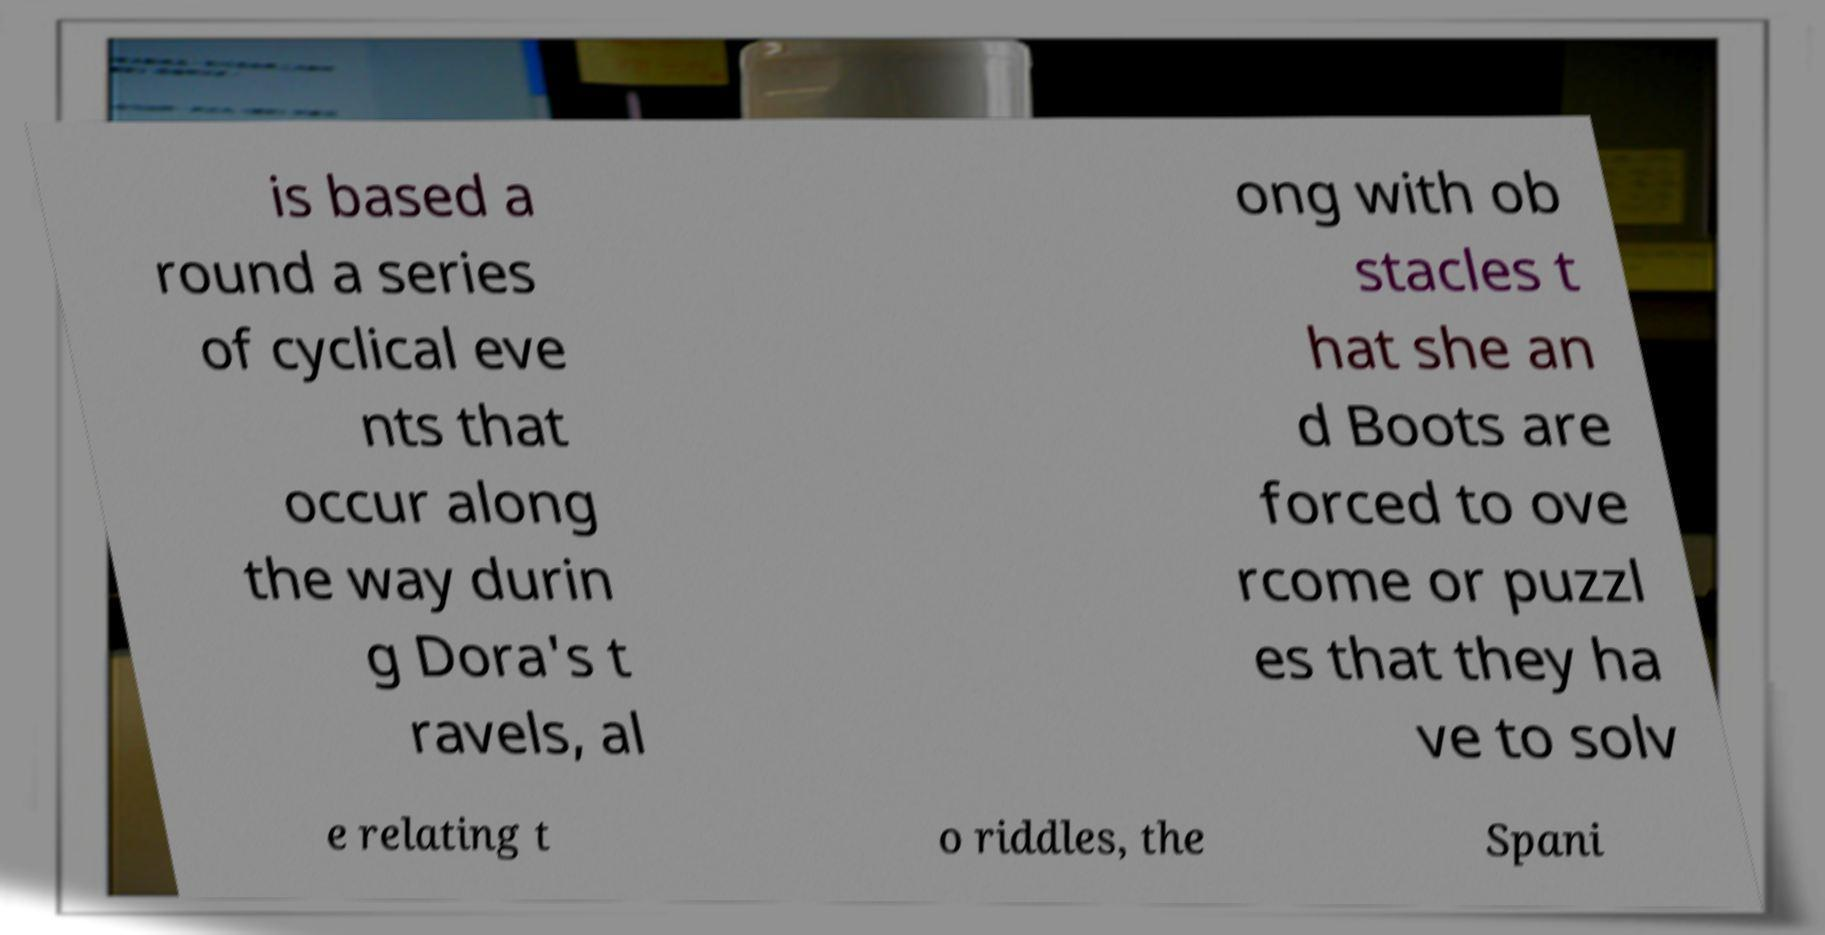Could you extract and type out the text from this image? is based a round a series of cyclical eve nts that occur along the way durin g Dora's t ravels, al ong with ob stacles t hat she an d Boots are forced to ove rcome or puzzl es that they ha ve to solv e relating t o riddles, the Spani 